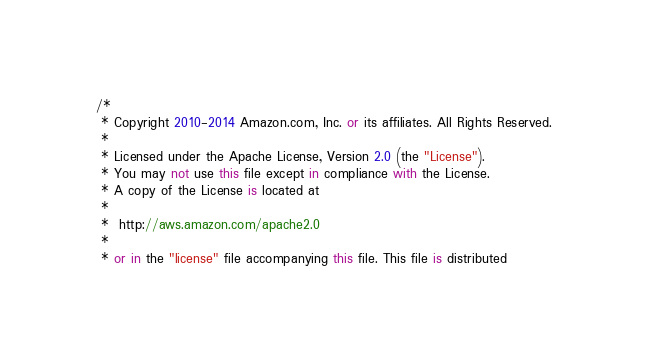Convert code to text. <code><loc_0><loc_0><loc_500><loc_500><_C#_>/*
 * Copyright 2010-2014 Amazon.com, Inc. or its affiliates. All Rights Reserved.
 * 
 * Licensed under the Apache License, Version 2.0 (the "License").
 * You may not use this file except in compliance with the License.
 * A copy of the License is located at
 * 
 *  http://aws.amazon.com/apache2.0
 * 
 * or in the "license" file accompanying this file. This file is distributed</code> 